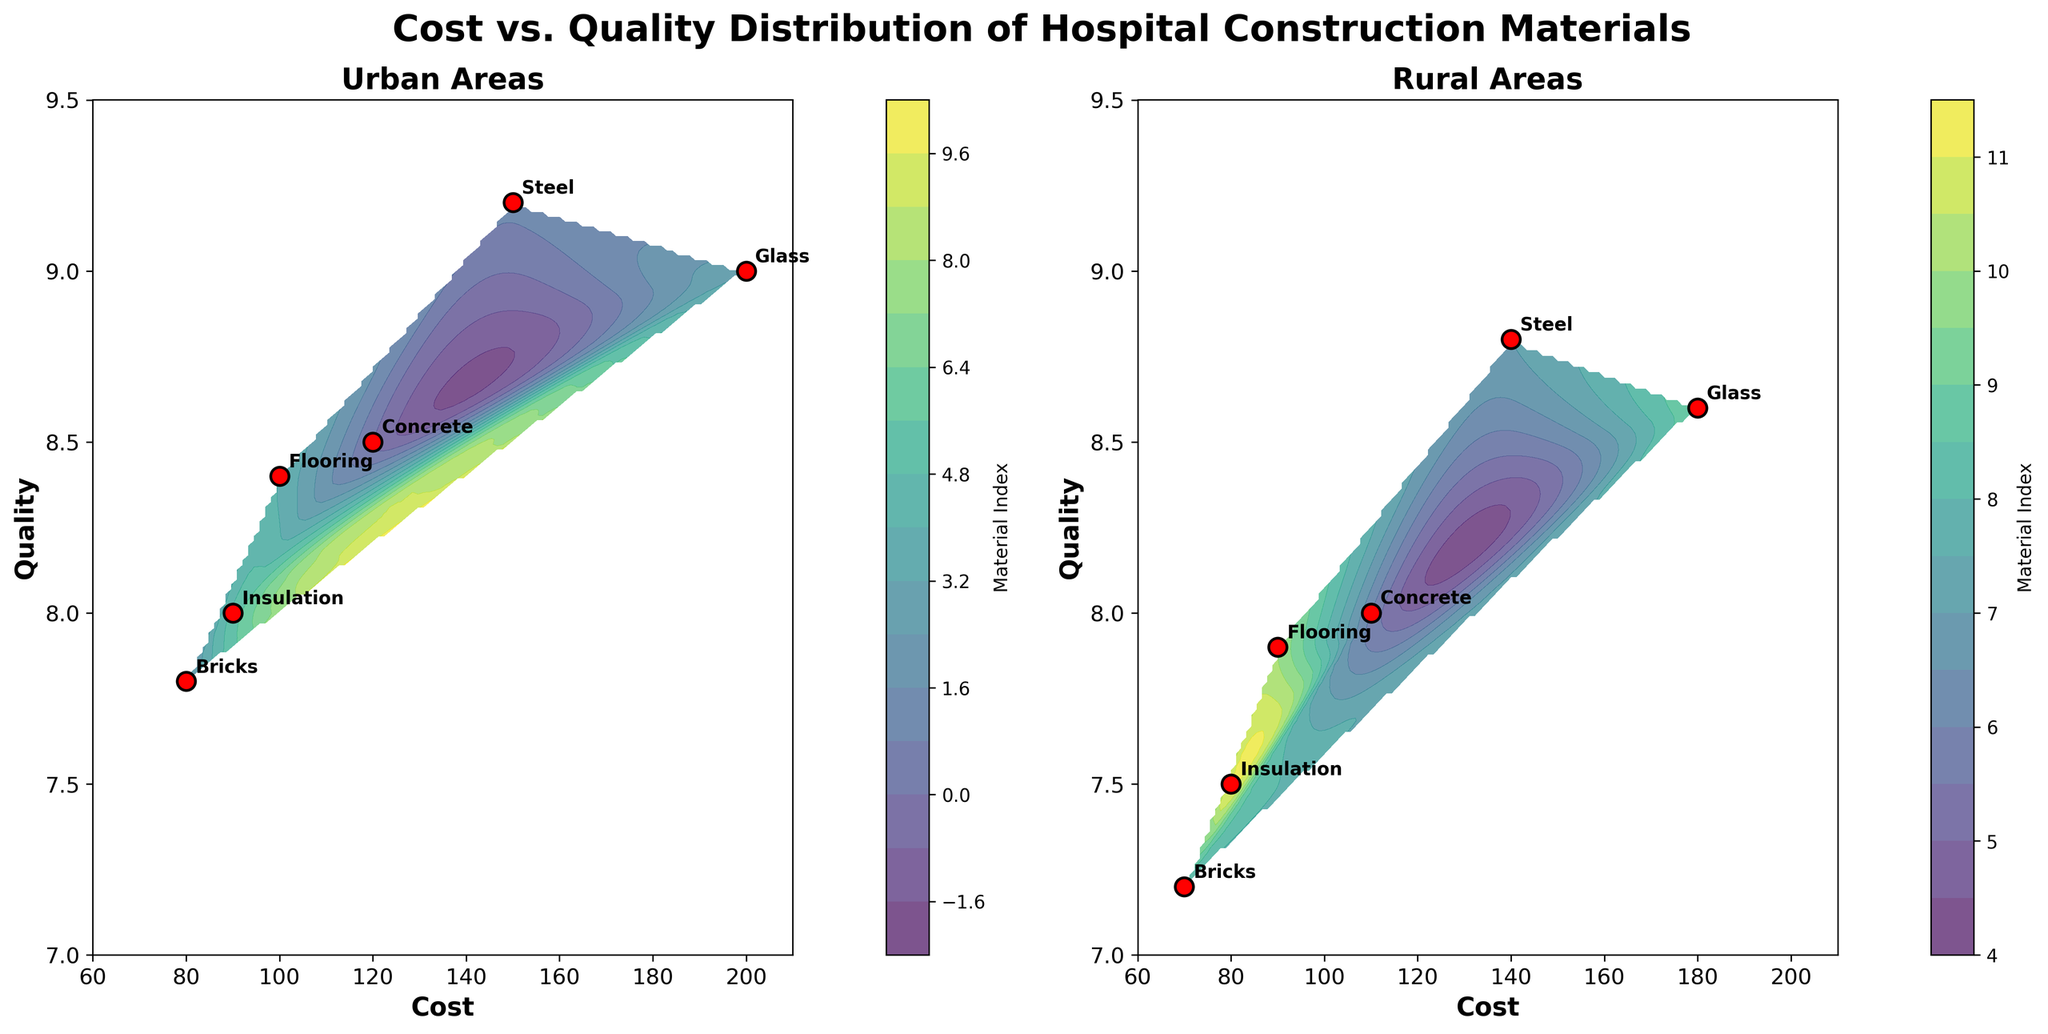What are the subplots in the figure titled? The figure has two subplots, each titled "Urban Areas" and "Rural Areas", respectively.
Answer: Urban Areas, Rural Areas How many materials are shown in urban areas? The plot for urban areas shows six materials. These can be identified by the labeled points in the subplot.
Answer: Six What is the cost range for materials in rural areas? The x-axis for the rural areas subplot ranges from 60 to 210, indicating that the cost of materials falls within this range.
Answer: 60 to 210 Which material has the highest quality rating in urban areas? By observing the urban areas subplot, the material labeled with the highest point on the y-axis is Steel, with a quality rating of 9.2.
Answer: Steel Which material is least costly in rural areas, and what is its corresponding quality rating? In the rural areas subplot, the material with the lowest cost on the x-axis is Bricks, costing 70, and its corresponding quality rating is 7.2.
Answer: Bricks, 7.2 What is the difference in cost between the most expensive material in urban and rural areas? The urban area's most expensive material is Glass at 200, and the rural area's is also Glass at 180. The difference is 200 - 180 = 20.
Answer: 20 Compare the quality of Concrete between urban and rural areas. In the urban subplot, Concrete has a quality rating of 8.5, while in the rural subplot, its quality rating is 8.0. Thus, Concrete in urban areas has a higher quality rating.
Answer: Urban Concrete has higher quality Is there any overlap in the cost ranges of materials between urban and rural areas? Both subplots show that the cost ranges for materials in urban (80-200) and rural (70-180) areas overlap.
Answer: Yes Which area has a material with a higher maximum quality rating? By comparing the highest points on the y-axes of both subplots, it is evident that the urban subplot's highest quality rating (Steel at 9.2) is greater than the rural subplot's highest rating (Steel at 8.8).
Answer: Urban What is the average quality of materials in rural areas? By summing the quality ratings of all materials in rural areas (8.0 + 8.8 + 7.2 + 8.6 + 7.9 + 7.5 = 48) and dividing by the number of materials (6), the average quality is 48 / 6 = 8.
Answer: 8 